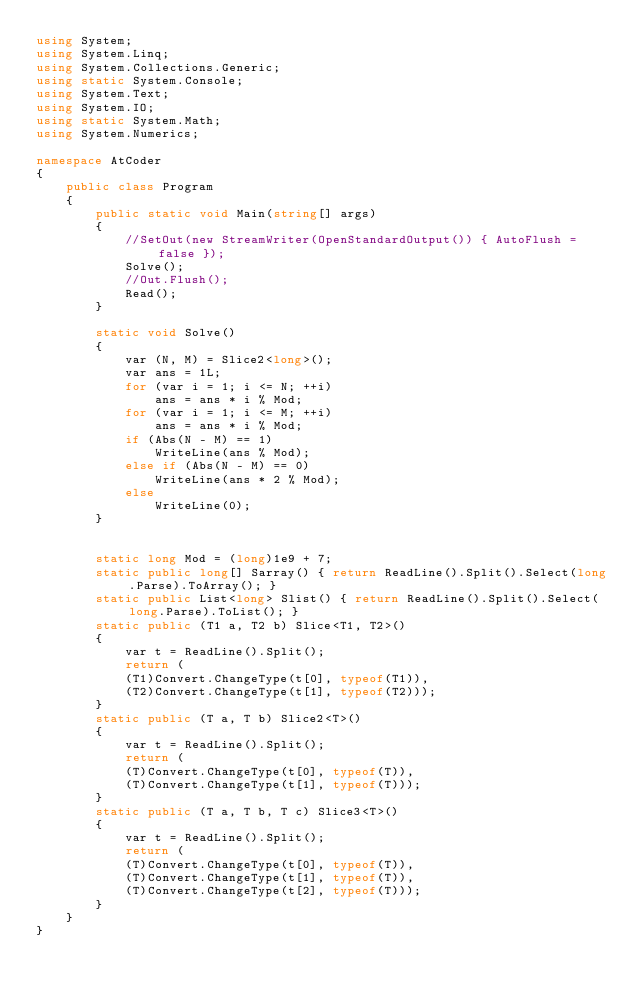Convert code to text. <code><loc_0><loc_0><loc_500><loc_500><_C#_>using System;
using System.Linq;
using System.Collections.Generic;
using static System.Console;
using System.Text;
using System.IO;
using static System.Math;
using System.Numerics;

namespace AtCoder
{
    public class Program
    {
        public static void Main(string[] args)
        {
            //SetOut(new StreamWriter(OpenStandardOutput()) { AutoFlush = false });
            Solve();
            //Out.Flush();
            Read();
        }

        static void Solve()
        {
            var (N, M) = Slice2<long>();
            var ans = 1L;
            for (var i = 1; i <= N; ++i)
                ans = ans * i % Mod;
            for (var i = 1; i <= M; ++i)
                ans = ans * i % Mod;
            if (Abs(N - M) == 1)
                WriteLine(ans % Mod);
            else if (Abs(N - M) == 0)
                WriteLine(ans * 2 % Mod);
            else
                WriteLine(0);
        }


        static long Mod = (long)1e9 + 7;
        static public long[] Sarray() { return ReadLine().Split().Select(long.Parse).ToArray(); }
        static public List<long> Slist() { return ReadLine().Split().Select(long.Parse).ToList(); }
        static public (T1 a, T2 b) Slice<T1, T2>()
        {
            var t = ReadLine().Split();
            return (
            (T1)Convert.ChangeType(t[0], typeof(T1)),
            (T2)Convert.ChangeType(t[1], typeof(T2)));
        }
        static public (T a, T b) Slice2<T>()
        {
            var t = ReadLine().Split();
            return (
            (T)Convert.ChangeType(t[0], typeof(T)),
            (T)Convert.ChangeType(t[1], typeof(T)));
        }
        static public (T a, T b, T c) Slice3<T>()
        {
            var t = ReadLine().Split();
            return (
            (T)Convert.ChangeType(t[0], typeof(T)),
            (T)Convert.ChangeType(t[1], typeof(T)),
            (T)Convert.ChangeType(t[2], typeof(T)));
        }
    }
}</code> 